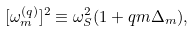<formula> <loc_0><loc_0><loc_500><loc_500>[ \omega _ { m } ^ { ( q ) } ] ^ { 2 } \equiv \omega _ { S } ^ { 2 } ( 1 + q m \Delta _ { m } ) ,</formula> 